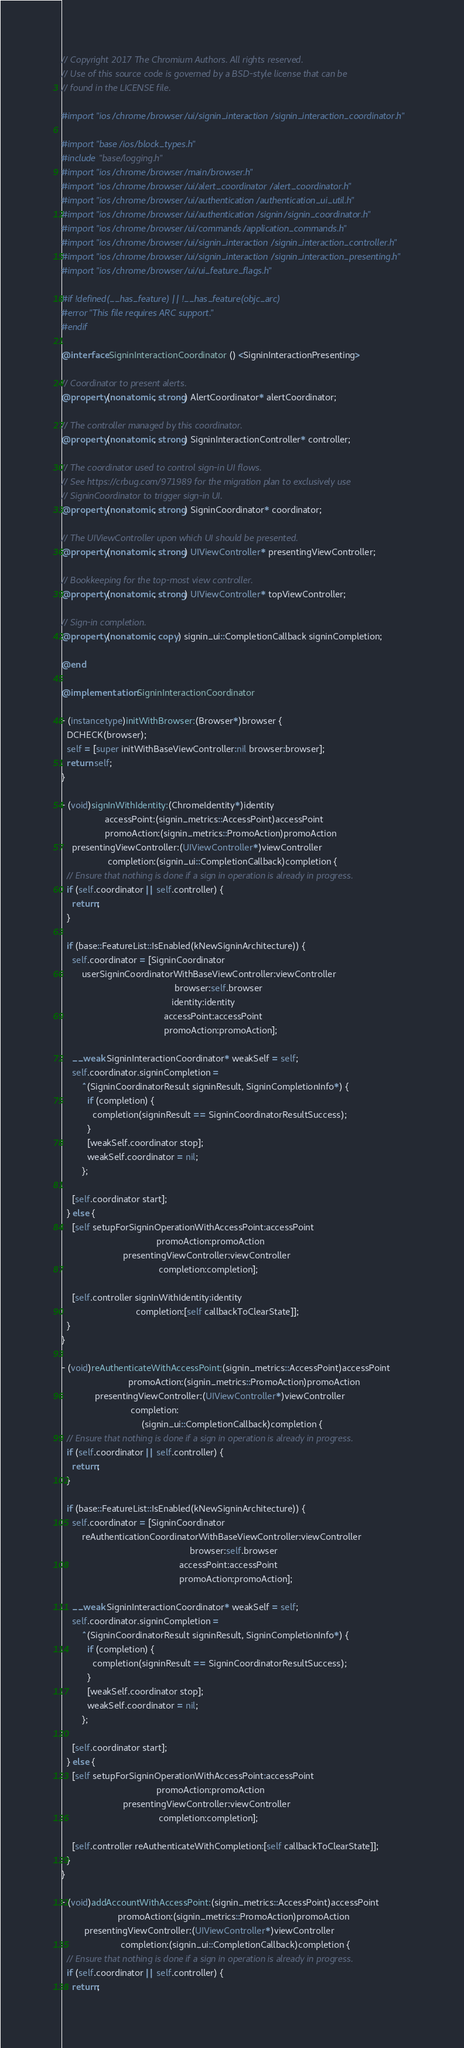Convert code to text. <code><loc_0><loc_0><loc_500><loc_500><_ObjectiveC_>// Copyright 2017 The Chromium Authors. All rights reserved.
// Use of this source code is governed by a BSD-style license that can be
// found in the LICENSE file.

#import "ios/chrome/browser/ui/signin_interaction/signin_interaction_coordinator.h"

#import "base/ios/block_types.h"
#include "base/logging.h"
#import "ios/chrome/browser/main/browser.h"
#import "ios/chrome/browser/ui/alert_coordinator/alert_coordinator.h"
#import "ios/chrome/browser/ui/authentication/authentication_ui_util.h"
#import "ios/chrome/browser/ui/authentication/signin/signin_coordinator.h"
#import "ios/chrome/browser/ui/commands/application_commands.h"
#import "ios/chrome/browser/ui/signin_interaction/signin_interaction_controller.h"
#import "ios/chrome/browser/ui/signin_interaction/signin_interaction_presenting.h"
#import "ios/chrome/browser/ui/ui_feature_flags.h"

#if !defined(__has_feature) || !__has_feature(objc_arc)
#error "This file requires ARC support."
#endif

@interface SigninInteractionCoordinator () <SigninInteractionPresenting>

// Coordinator to present alerts.
@property(nonatomic, strong) AlertCoordinator* alertCoordinator;

// The controller managed by this coordinator.
@property(nonatomic, strong) SigninInteractionController* controller;

// The coordinator used to control sign-in UI flows.
// See https://crbug.com/971989 for the migration plan to exclusively use
// SigninCoordinator to trigger sign-in UI.
@property(nonatomic, strong) SigninCoordinator* coordinator;

// The UIViewController upon which UI should be presented.
@property(nonatomic, strong) UIViewController* presentingViewController;

// Bookkeeping for the top-most view controller.
@property(nonatomic, strong) UIViewController* topViewController;

// Sign-in completion.
@property(nonatomic, copy) signin_ui::CompletionCallback signinCompletion;

@end

@implementation SigninInteractionCoordinator

- (instancetype)initWithBrowser:(Browser*)browser {
  DCHECK(browser);
  self = [super initWithBaseViewController:nil browser:browser];
  return self;
}

- (void)signInWithIdentity:(ChromeIdentity*)identity
                 accessPoint:(signin_metrics::AccessPoint)accessPoint
                 promoAction:(signin_metrics::PromoAction)promoAction
    presentingViewController:(UIViewController*)viewController
                  completion:(signin_ui::CompletionCallback)completion {
  // Ensure that nothing is done if a sign in operation is already in progress.
  if (self.coordinator || self.controller) {
    return;
  }

  if (base::FeatureList::IsEnabled(kNewSigninArchitecture)) {
    self.coordinator = [SigninCoordinator
        userSigninCoordinatorWithBaseViewController:viewController
                                            browser:self.browser
                                           identity:identity
                                        accessPoint:accessPoint
                                        promoAction:promoAction];

    __weak SigninInteractionCoordinator* weakSelf = self;
    self.coordinator.signinCompletion =
        ^(SigninCoordinatorResult signinResult, SigninCompletionInfo*) {
          if (completion) {
            completion(signinResult == SigninCoordinatorResultSuccess);
          }
          [weakSelf.coordinator stop];
          weakSelf.coordinator = nil;
        };

    [self.coordinator start];
  } else {
    [self setupForSigninOperationWithAccessPoint:accessPoint
                                     promoAction:promoAction
                        presentingViewController:viewController
                                      completion:completion];

    [self.controller signInWithIdentity:identity
                             completion:[self callbackToClearState]];
  }
}

- (void)reAuthenticateWithAccessPoint:(signin_metrics::AccessPoint)accessPoint
                          promoAction:(signin_metrics::PromoAction)promoAction
             presentingViewController:(UIViewController*)viewController
                           completion:
                               (signin_ui::CompletionCallback)completion {
  // Ensure that nothing is done if a sign in operation is already in progress.
  if (self.coordinator || self.controller) {
    return;
  }

  if (base::FeatureList::IsEnabled(kNewSigninArchitecture)) {
    self.coordinator = [SigninCoordinator
        reAuthenticationCoordinatorWithBaseViewController:viewController
                                                  browser:self.browser
                                              accessPoint:accessPoint
                                              promoAction:promoAction];

    __weak SigninInteractionCoordinator* weakSelf = self;
    self.coordinator.signinCompletion =
        ^(SigninCoordinatorResult signinResult, SigninCompletionInfo*) {
          if (completion) {
            completion(signinResult == SigninCoordinatorResultSuccess);
          }
          [weakSelf.coordinator stop];
          weakSelf.coordinator = nil;
        };

    [self.coordinator start];
  } else {
    [self setupForSigninOperationWithAccessPoint:accessPoint
                                     promoAction:promoAction
                        presentingViewController:viewController
                                      completion:completion];

    [self.controller reAuthenticateWithCompletion:[self callbackToClearState]];
  }
}

- (void)addAccountWithAccessPoint:(signin_metrics::AccessPoint)accessPoint
                      promoAction:(signin_metrics::PromoAction)promoAction
         presentingViewController:(UIViewController*)viewController
                       completion:(signin_ui::CompletionCallback)completion {
  // Ensure that nothing is done if a sign in operation is already in progress.
  if (self.coordinator || self.controller) {
    return;</code> 